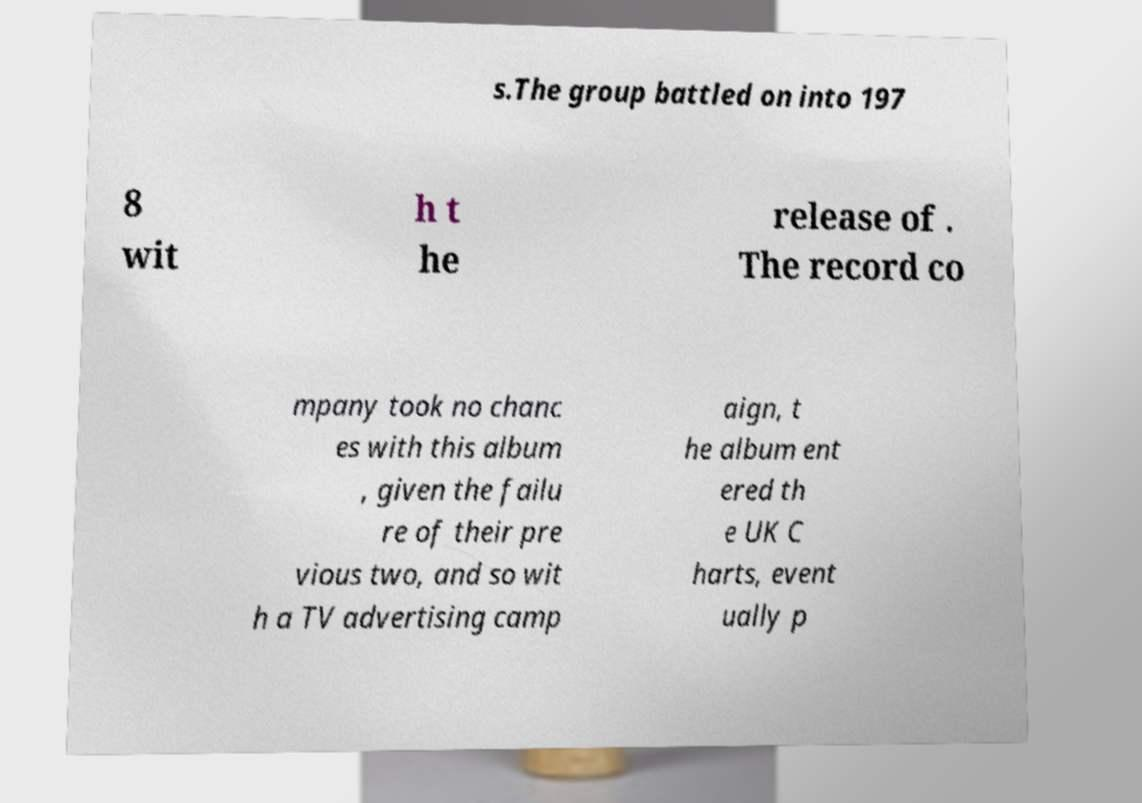Could you extract and type out the text from this image? s.The group battled on into 197 8 wit h t he release of . The record co mpany took no chanc es with this album , given the failu re of their pre vious two, and so wit h a TV advertising camp aign, t he album ent ered th e UK C harts, event ually p 